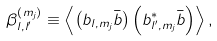Convert formula to latex. <formula><loc_0><loc_0><loc_500><loc_500>\beta _ { l , l ^ { \prime } } ^ { \left ( m _ { j } \right ) } \equiv \left \langle \left ( b _ { l , m _ { j } } \bar { b } \right ) \left ( b _ { l ^ { \prime } , m _ { j } } ^ { \ast } \bar { b } \right ) \right \rangle ,</formula> 